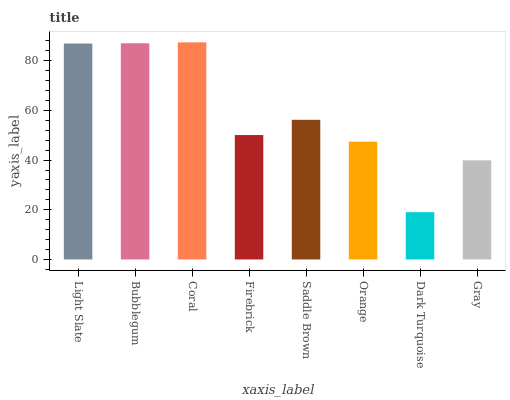Is Dark Turquoise the minimum?
Answer yes or no. Yes. Is Coral the maximum?
Answer yes or no. Yes. Is Bubblegum the minimum?
Answer yes or no. No. Is Bubblegum the maximum?
Answer yes or no. No. Is Bubblegum greater than Light Slate?
Answer yes or no. Yes. Is Light Slate less than Bubblegum?
Answer yes or no. Yes. Is Light Slate greater than Bubblegum?
Answer yes or no. No. Is Bubblegum less than Light Slate?
Answer yes or no. No. Is Saddle Brown the high median?
Answer yes or no. Yes. Is Firebrick the low median?
Answer yes or no. Yes. Is Firebrick the high median?
Answer yes or no. No. Is Orange the low median?
Answer yes or no. No. 